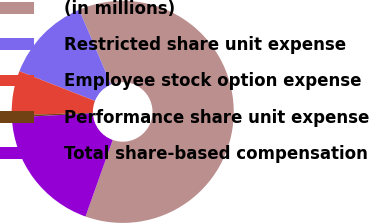<chart> <loc_0><loc_0><loc_500><loc_500><pie_chart><fcel>(in millions)<fcel>Restricted share unit expense<fcel>Employee stock option expense<fcel>Performance share unit expense<fcel>Total share-based compensation<nl><fcel>61.85%<fcel>12.61%<fcel>6.46%<fcel>0.31%<fcel>18.77%<nl></chart> 